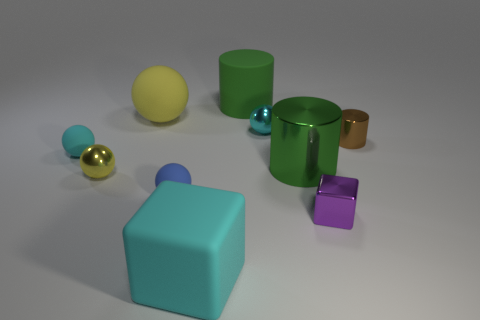The thing that is both left of the large green rubber cylinder and in front of the tiny blue sphere is what color?
Provide a short and direct response. Cyan. What material is the big yellow object that is on the left side of the cube on the left side of the tiny purple metallic block?
Provide a short and direct response. Rubber. The cyan matte thing that is the same shape as the tiny yellow metal thing is what size?
Give a very brief answer. Small. There is a cylinder that is in front of the brown cylinder; is its color the same as the large matte cylinder?
Offer a terse response. Yes. Is the number of brown shiny things less than the number of shiny balls?
Ensure brevity in your answer.  Yes. What number of other things are there of the same color as the large cube?
Ensure brevity in your answer.  2. Does the object in front of the purple thing have the same material as the big yellow object?
Your answer should be very brief. Yes. What is the large object right of the big green matte cylinder made of?
Provide a short and direct response. Metal. What is the size of the yellow ball that is behind the cyan sphere that is on the left side of the big yellow rubber thing?
Keep it short and to the point. Large. Are there any large green things made of the same material as the large cyan cube?
Your response must be concise. Yes. 